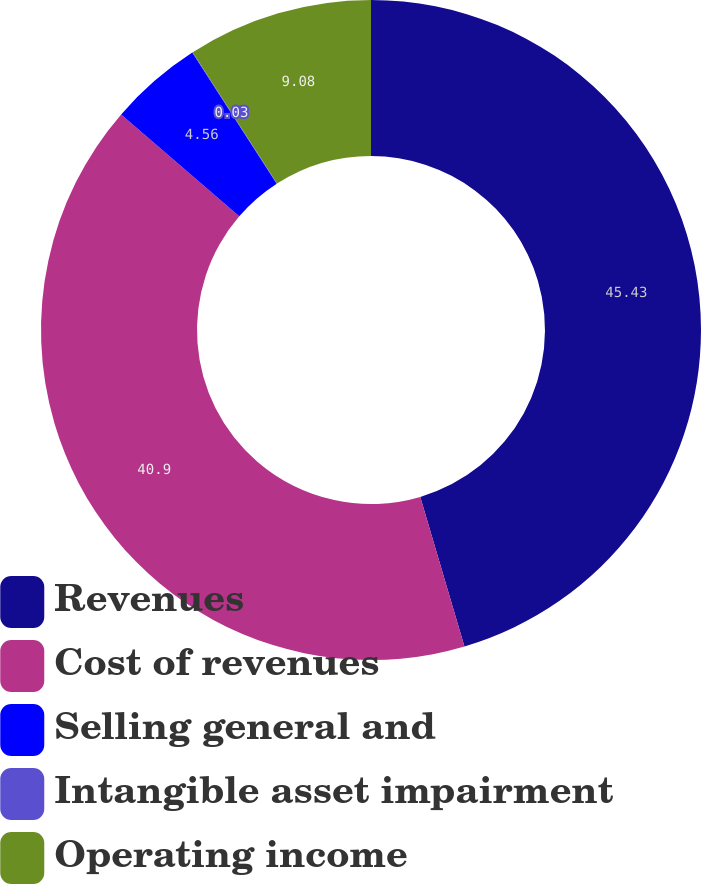Convert chart. <chart><loc_0><loc_0><loc_500><loc_500><pie_chart><fcel>Revenues<fcel>Cost of revenues<fcel>Selling general and<fcel>Intangible asset impairment<fcel>Operating income<nl><fcel>45.43%<fcel>40.9%<fcel>4.56%<fcel>0.03%<fcel>9.08%<nl></chart> 